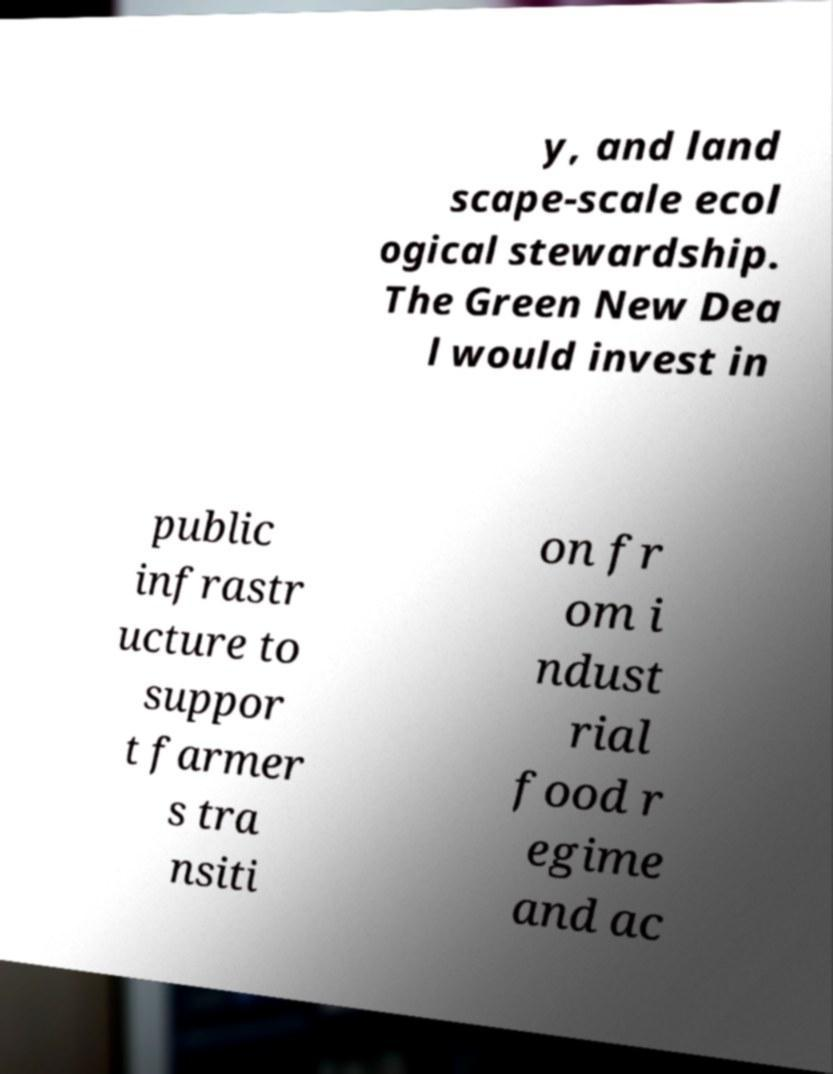Can you accurately transcribe the text from the provided image for me? y, and land scape-scale ecol ogical stewardship. The Green New Dea l would invest in public infrastr ucture to suppor t farmer s tra nsiti on fr om i ndust rial food r egime and ac 